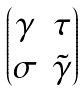Convert formula to latex. <formula><loc_0><loc_0><loc_500><loc_500>\begin{pmatrix} \gamma & \tau \\ \sigma & \tilde { \gamma } \end{pmatrix}</formula> 